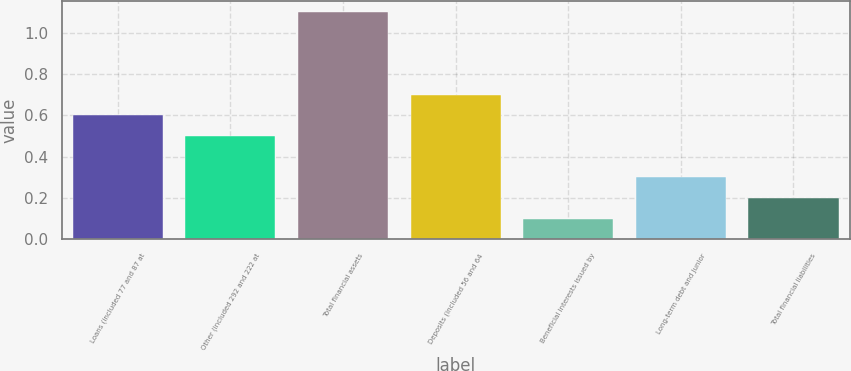<chart> <loc_0><loc_0><loc_500><loc_500><bar_chart><fcel>Loans (included 77 and 87 at<fcel>Other (included 292 and 222 at<fcel>Total financial assets<fcel>Deposits (included 56 and 64<fcel>Beneficial interests issued by<fcel>Long-term debt and junior<fcel>Total financial liabilities<nl><fcel>0.6<fcel>0.5<fcel>1.1<fcel>0.7<fcel>0.1<fcel>0.3<fcel>0.2<nl></chart> 